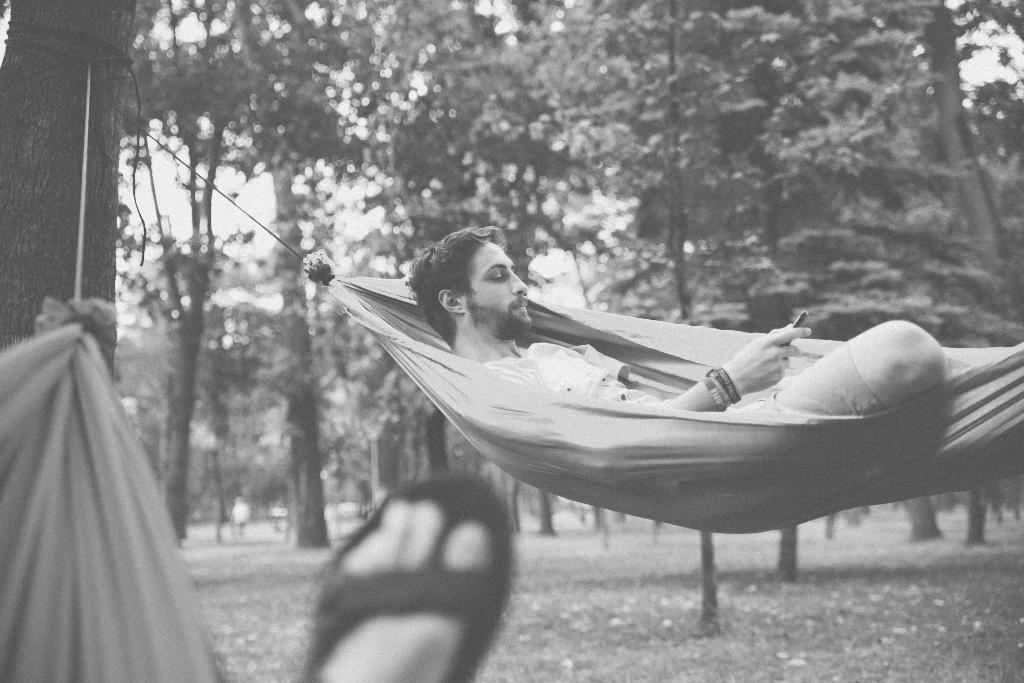Could you give a brief overview of what you see in this image? In the image we can see a man wearing clothes, bracelets and he is holding a gadget in his hand. Here we can see human leg, we can see trees and the sky. 